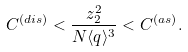<formula> <loc_0><loc_0><loc_500><loc_500>C ^ { ( d i s ) } < \frac { z _ { 2 } ^ { 2 } } { N \langle q \rangle ^ { 3 } } < C ^ { ( a s ) } .</formula> 